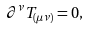<formula> <loc_0><loc_0><loc_500><loc_500>\partial ^ { \nu } T _ { ( \mu \nu ) } = 0 ,</formula> 